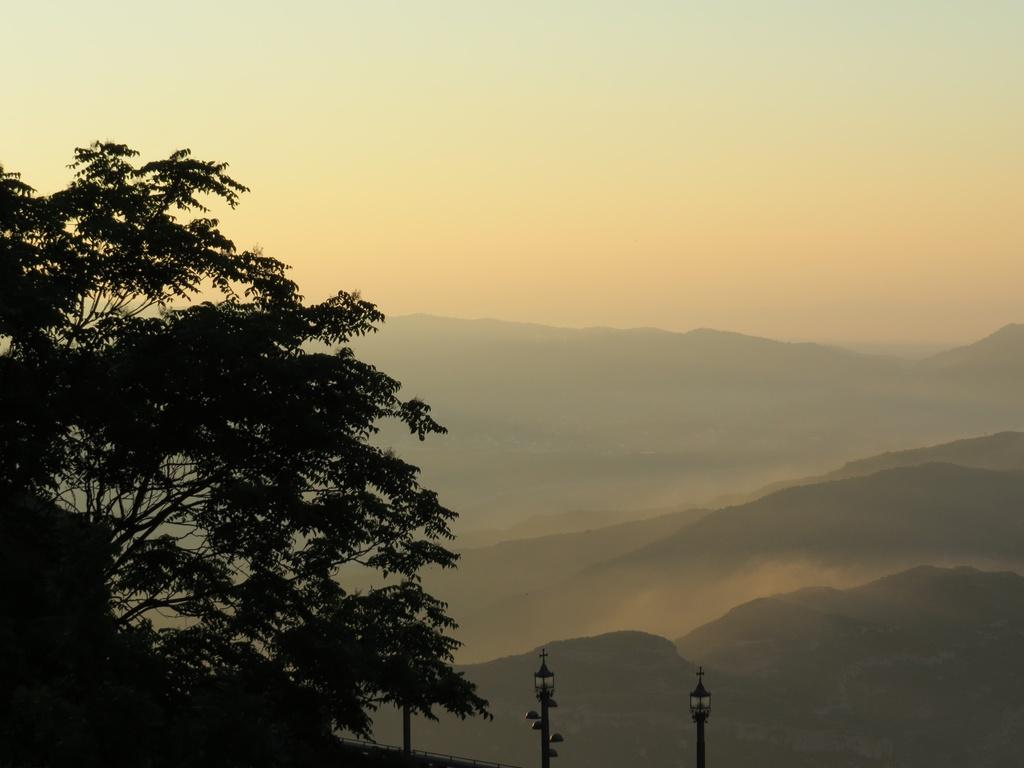What type of vegetation is present at the bottom of the image? There are trees at the bottom of the image. What type of man-made structures can be seen at the bottom of the image? There are street lights at the bottom of the image. What type of natural landforms are in the middle of the image? There are hills in the middle of the image. What part of the natural environment is visible in the image? The sky is visible in the image. Where is the church located in the image? There is no church present in the image. What type of range can be seen in the image? There is no range present in the image. 